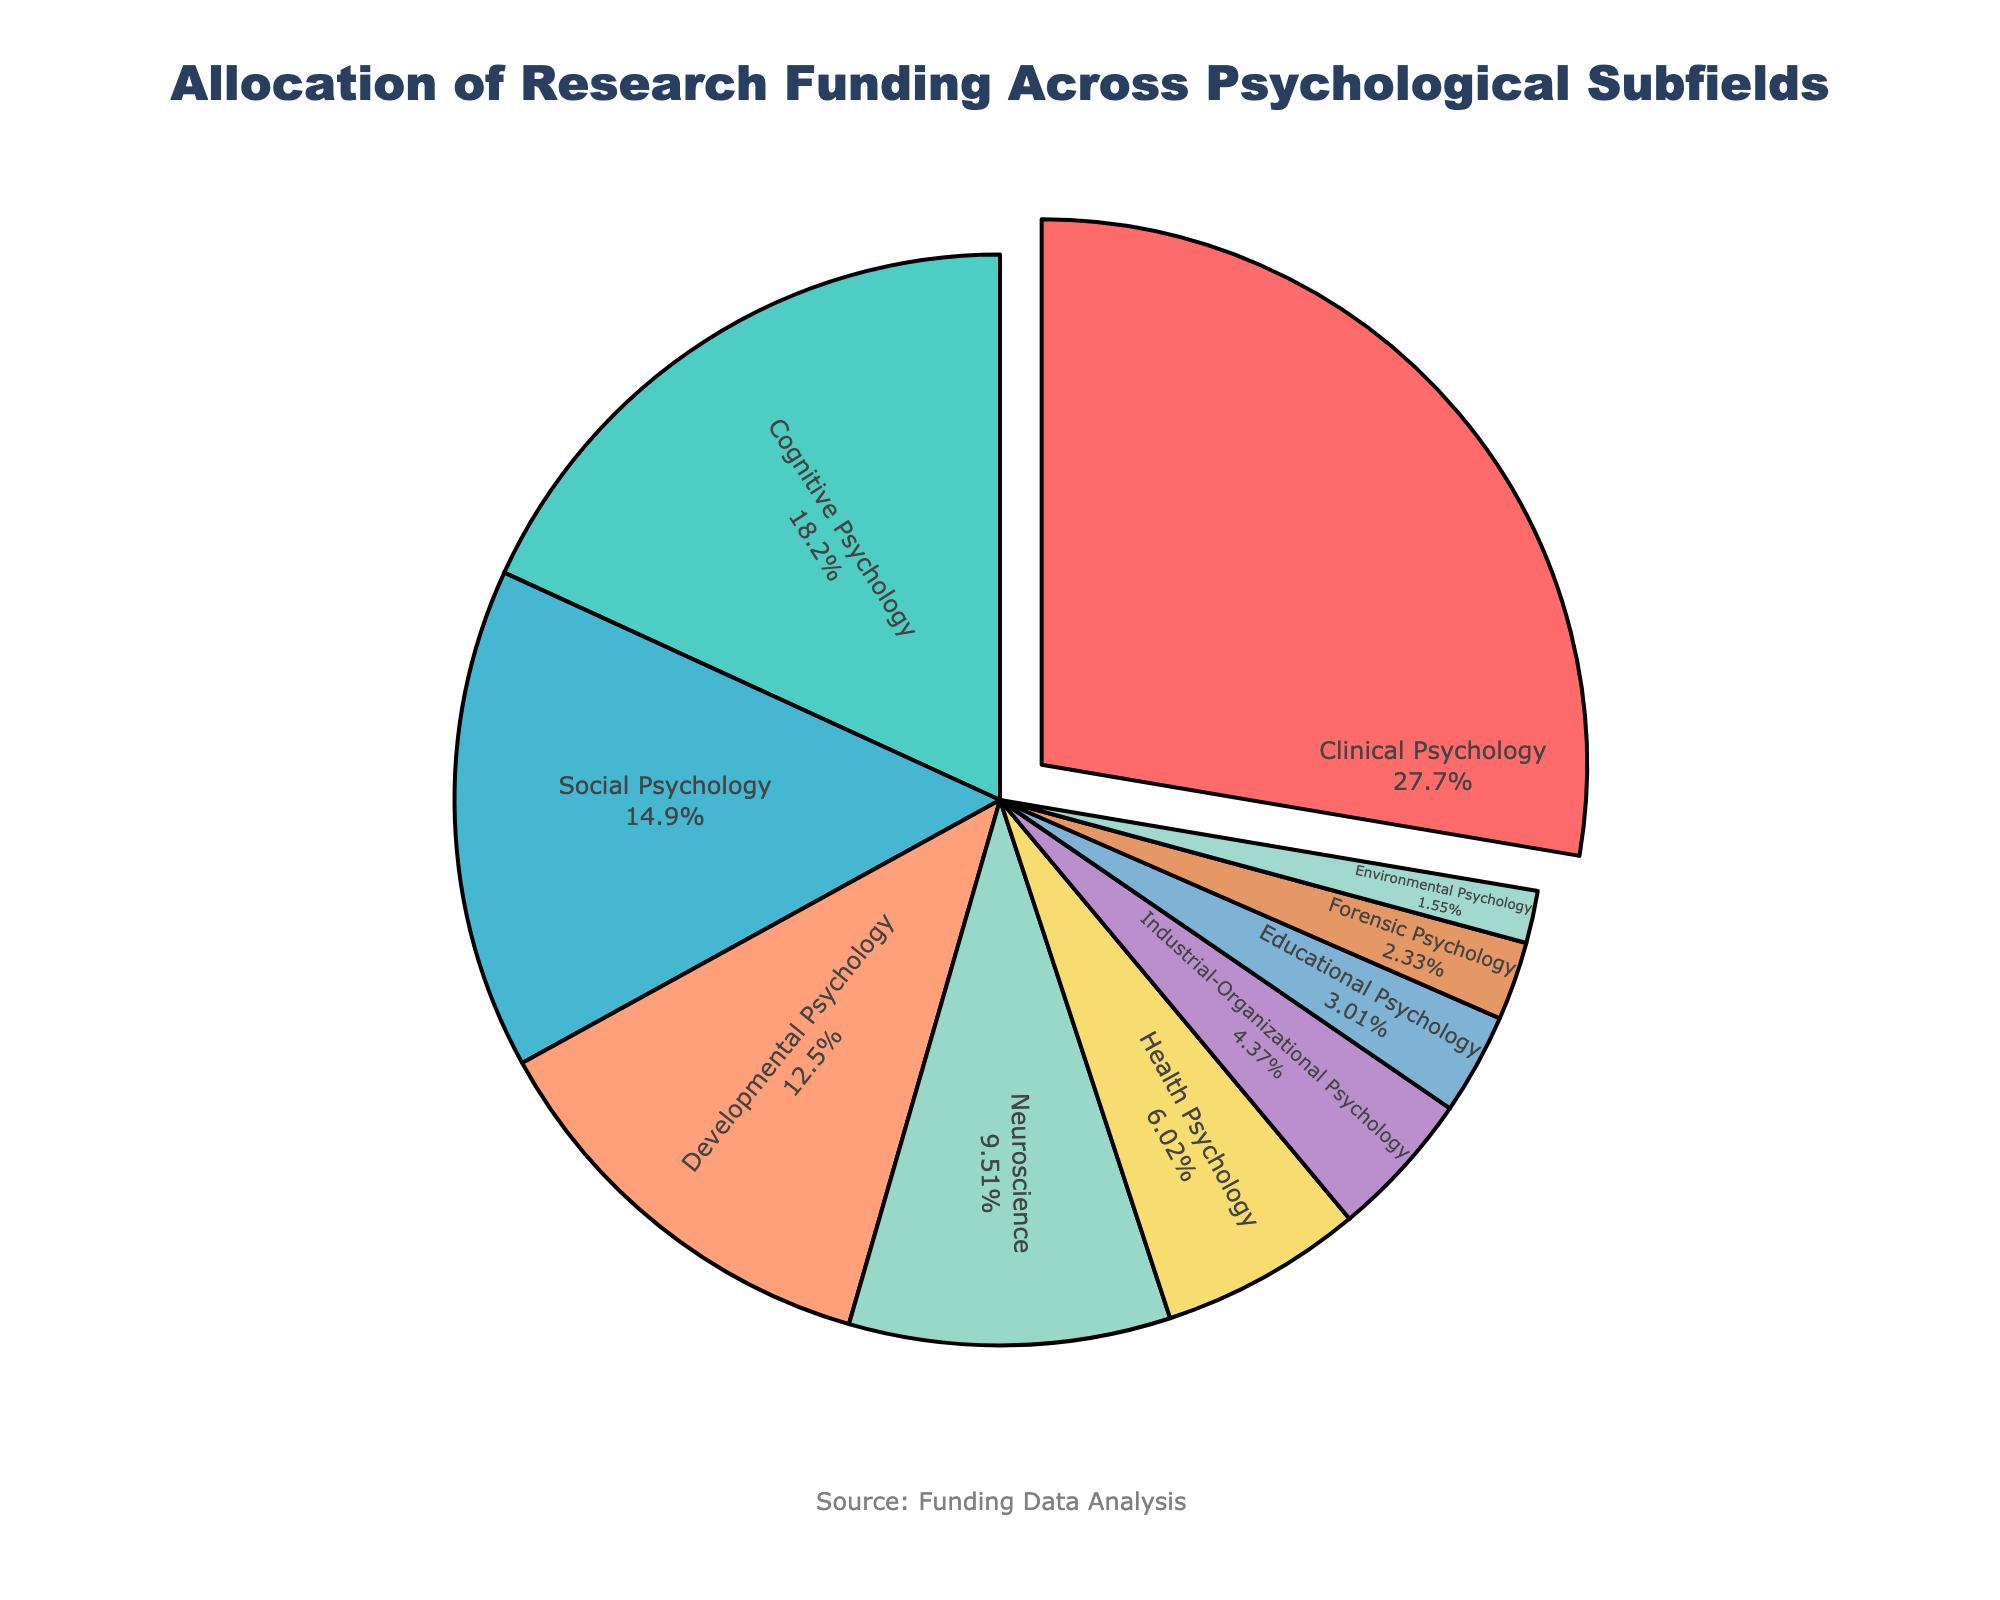What percent of the funding is allocated to Clinical Psychology and Cognitive Psychology combined? The funding for Clinical Psychology is 28.5%, and for Cognitive Psychology, it is 18.7%. Adding these together gives us 28.5% + 18.7% = 47.2%.
Answer: 47.2% Which subfield receives more funding, Developmental Psychology or Neuroscience? Developmental Psychology has 12.9% funding, while Neuroscience has 9.8%. Since 12.9% is greater than 9.8%, Developmental Psychology receives more funding.
Answer: Developmental Psychology What is the total percentage of funding allocated to subfields that receive less than 5% each? The subfields receiving less than 5% are Industrial-Organizational Psychology (4.5%), Educational Psychology (3.1%), Forensic Psychology (2.4%), and Environmental Psychology (1.6%). Adding these together: 4.5% + 3.1% + 2.4% + 1.6% = 11.6%.
Answer: 11.6% What funding percentage does Educational Psychology receive? From the chart, Educational Psychology receives 3.1% of the total funding.
Answer: 3.1% Between Health Psychology and Forensic Psychology, which subfield receives a lower percentage of funding, and by how much? Health Psychology receives 6.2%, while Forensic Psychology receives 2.4%. The difference is 6.2% - 2.4% = 3.8%. Forensic Psychology receives the lower percentage.
Answer: Forensic Psychology, 3.8% Which subfield is highlighted with a pull-out section, and what is its funding percentage? The subfield highlighted with a pull-out section is Clinical Psychology, which has a funding percentage of 28.5%.
Answer: Clinical Psychology, 28.5% Is the funding percentage for Environmental Psychology less than that for Industrial-Organizational Psychology? Yes, Environmental Psychology has a funding percentage of 1.6%, while Industrial-Organizational Psychology has 4.5%. Since 1.6% is less than 4.5%, the statement is true.
Answer: Yes What is the combined percentage of funding for Developmental Psychology and Social Psychology? Developmental Psychology has 12.9% funding, and Social Psychology has 15.3%. Adding these together: 12.9% + 15.3% = 28.2%.
Answer: 28.2% 